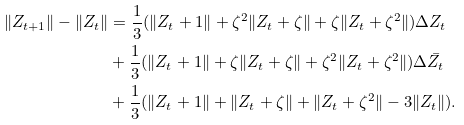<formula> <loc_0><loc_0><loc_500><loc_500>\| Z _ { t + 1 } \| - \| Z _ { t } \| & = \frac { 1 } { 3 } ( \| Z _ { t } + 1 \| + \zeta ^ { 2 } \| Z _ { t } + \zeta \| + \zeta \| Z _ { t } + \zeta ^ { 2 } \| ) \Delta Z _ { t } \\ & + \frac { 1 } { 3 } ( \| Z _ { t } + 1 \| + \zeta \| Z _ { t } + \zeta \| + \zeta ^ { 2 } \| Z _ { t } + \zeta ^ { 2 } \| ) \Delta \bar { Z } _ { t } \\ & + \frac { 1 } { 3 } ( \| Z _ { t } + 1 \| + \| Z _ { t } + \zeta \| + \| Z _ { t } + \zeta ^ { 2 } \| - 3 \| Z _ { t } \| ) .</formula> 